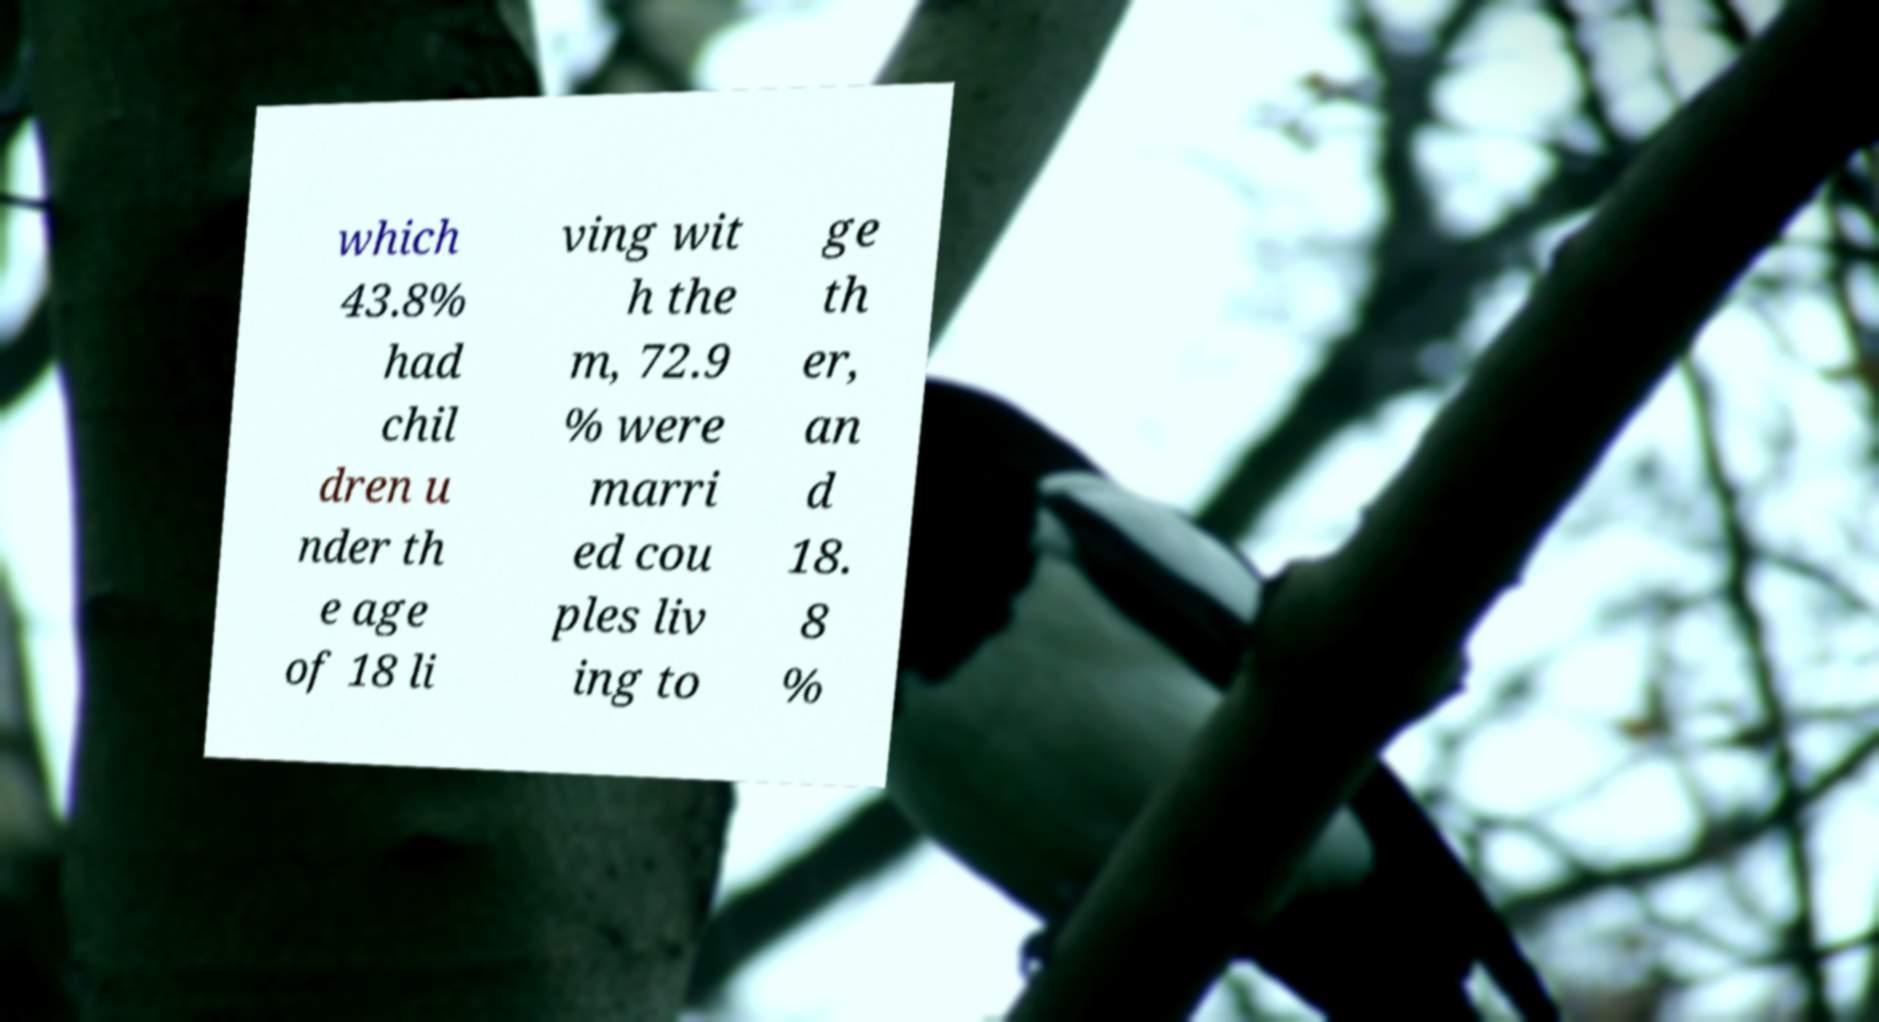Can you read and provide the text displayed in the image?This photo seems to have some interesting text. Can you extract and type it out for me? which 43.8% had chil dren u nder th e age of 18 li ving wit h the m, 72.9 % were marri ed cou ples liv ing to ge th er, an d 18. 8 % 